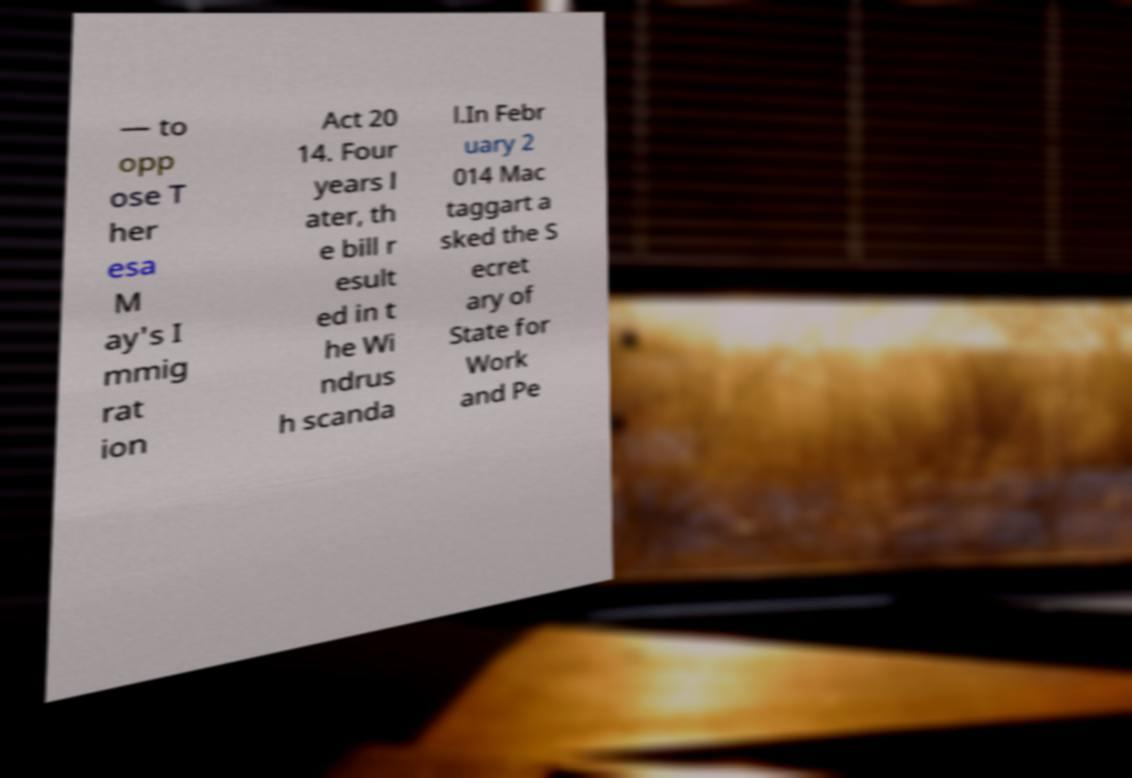Please identify and transcribe the text found in this image. — to opp ose T her esa M ay's I mmig rat ion Act 20 14. Four years l ater, th e bill r esult ed in t he Wi ndrus h scanda l.In Febr uary 2 014 Mac taggart a sked the S ecret ary of State for Work and Pe 